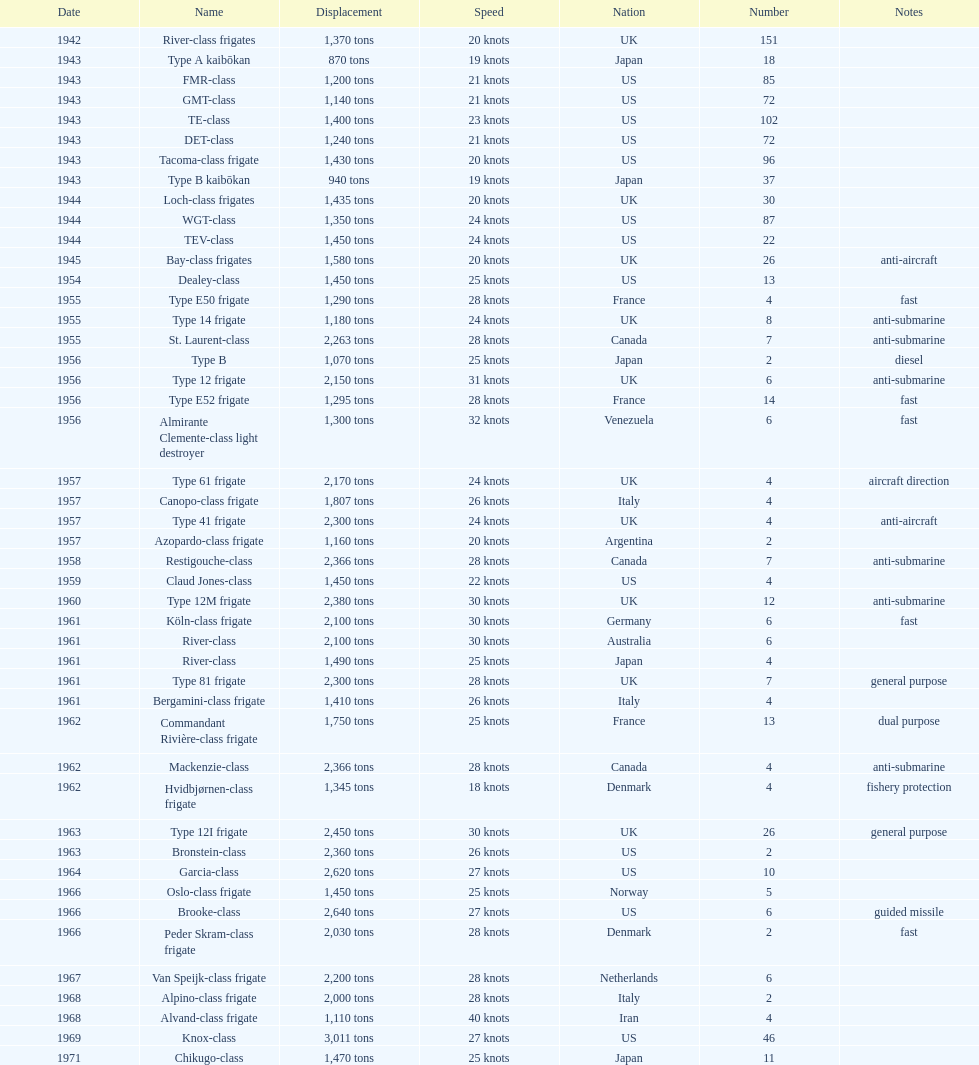Which name has the largest displacement? Knox-class. 